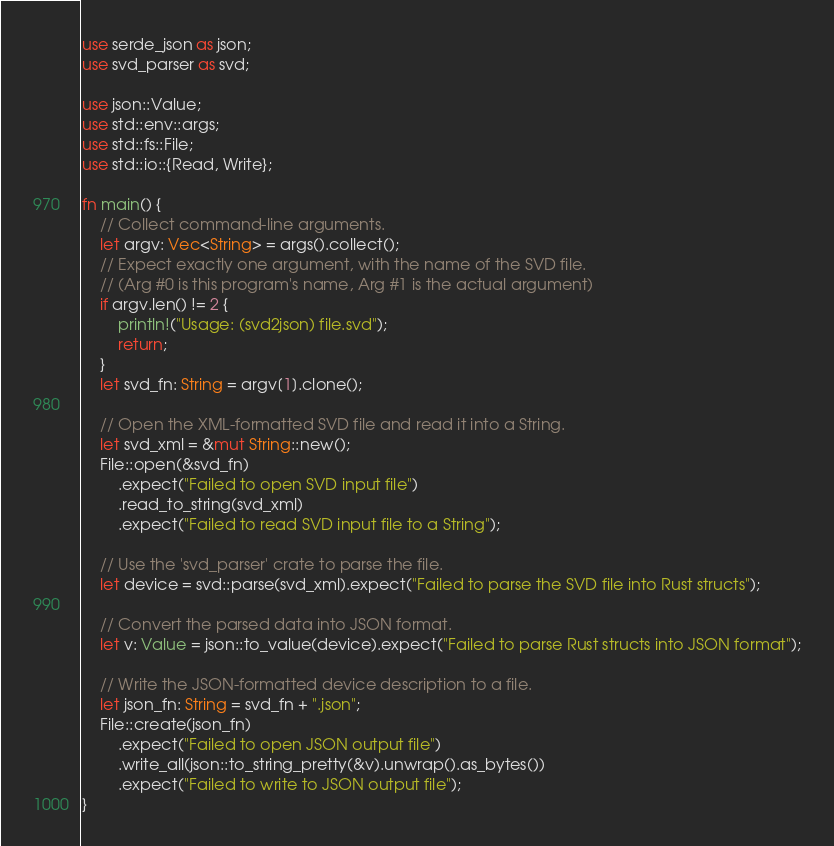Convert code to text. <code><loc_0><loc_0><loc_500><loc_500><_Rust_>use serde_json as json;
use svd_parser as svd;

use json::Value;
use std::env::args;
use std::fs::File;
use std::io::{Read, Write};

fn main() {
    // Collect command-line arguments.
    let argv: Vec<String> = args().collect();
    // Expect exactly one argument, with the name of the SVD file.
    // (Arg #0 is this program's name, Arg #1 is the actual argument)
    if argv.len() != 2 {
        println!("Usage: (svd2json) file.svd");
        return;
    }
    let svd_fn: String = argv[1].clone();

    // Open the XML-formatted SVD file and read it into a String.
    let svd_xml = &mut String::new();
    File::open(&svd_fn)
        .expect("Failed to open SVD input file")
        .read_to_string(svd_xml)
        .expect("Failed to read SVD input file to a String");

    // Use the 'svd_parser' crate to parse the file.
    let device = svd::parse(svd_xml).expect("Failed to parse the SVD file into Rust structs");

    // Convert the parsed data into JSON format.
    let v: Value = json::to_value(device).expect("Failed to parse Rust structs into JSON format");

    // Write the JSON-formatted device description to a file.
    let json_fn: String = svd_fn + ".json";
    File::create(json_fn)
        .expect("Failed to open JSON output file")
        .write_all(json::to_string_pretty(&v).unwrap().as_bytes())
        .expect("Failed to write to JSON output file");
}
</code> 